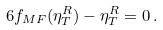Convert formula to latex. <formula><loc_0><loc_0><loc_500><loc_500>6 f _ { M F } ( \eta ^ { R } _ { T } ) - \eta ^ { R } _ { T } = 0 \, .</formula> 